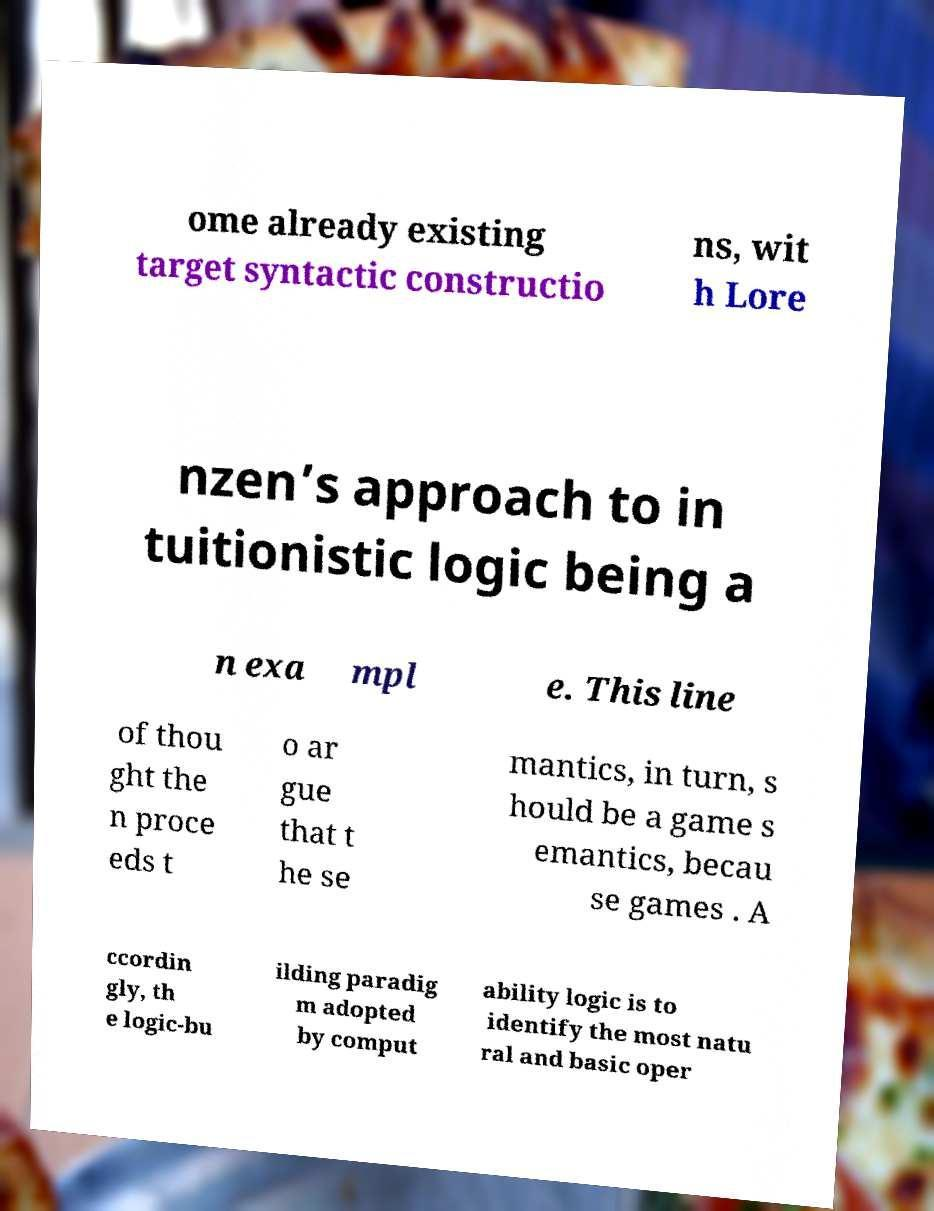There's text embedded in this image that I need extracted. Can you transcribe it verbatim? ome already existing target syntactic constructio ns, wit h Lore nzen’s approach to in tuitionistic logic being a n exa mpl e. This line of thou ght the n proce eds t o ar gue that t he se mantics, in turn, s hould be a game s emantics, becau se games . A ccordin gly, th e logic-bu ilding paradig m adopted by comput ability logic is to identify the most natu ral and basic oper 